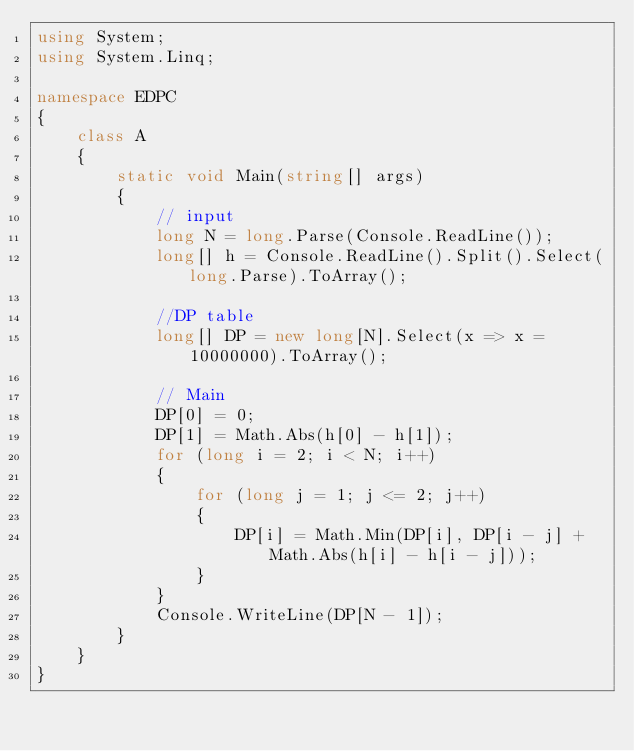<code> <loc_0><loc_0><loc_500><loc_500><_C#_>using System;
using System.Linq;

namespace EDPC
{
    class A
    {
        static void Main(string[] args)
        {
            // input
            long N = long.Parse(Console.ReadLine());
            long[] h = Console.ReadLine().Split().Select(long.Parse).ToArray();

            //DP table
            long[] DP = new long[N].Select(x => x = 10000000).ToArray();

            // Main
            DP[0] = 0;
            DP[1] = Math.Abs(h[0] - h[1]);
            for (long i = 2; i < N; i++)
            {
                for (long j = 1; j <= 2; j++)
                {
                    DP[i] = Math.Min(DP[i], DP[i - j] + Math.Abs(h[i] - h[i - j]));
                }
            }
            Console.WriteLine(DP[N - 1]);
        }
    }
}
</code> 